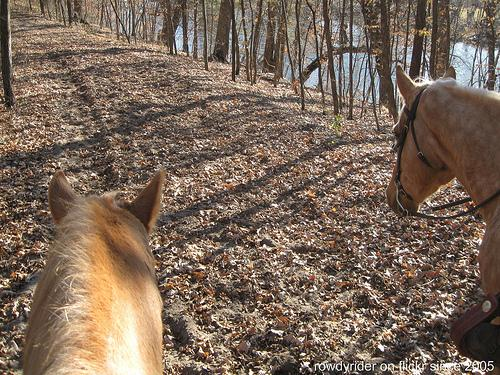Question: where was the pic taken?
Choices:
A. In the jungle.
B. In the desert.
C. In the woods.
D. In the tundra.
Answer with the letter. Answer: C Question: when was the pic taken?
Choices:
A. At night.
B. In the morning.
C. At sunset.
D. During the day.
Answer with the letter. Answer: D Question: what is the color of the horses?
Choices:
A. White.
B. Gray.
C. Black.
D. Brown.
Answer with the letter. Answer: D Question: what are they stepping on?
Choices:
A. Asphalt.
B. Leaves.
C. Gravel.
D. Dirt.
Answer with the letter. Answer: B 